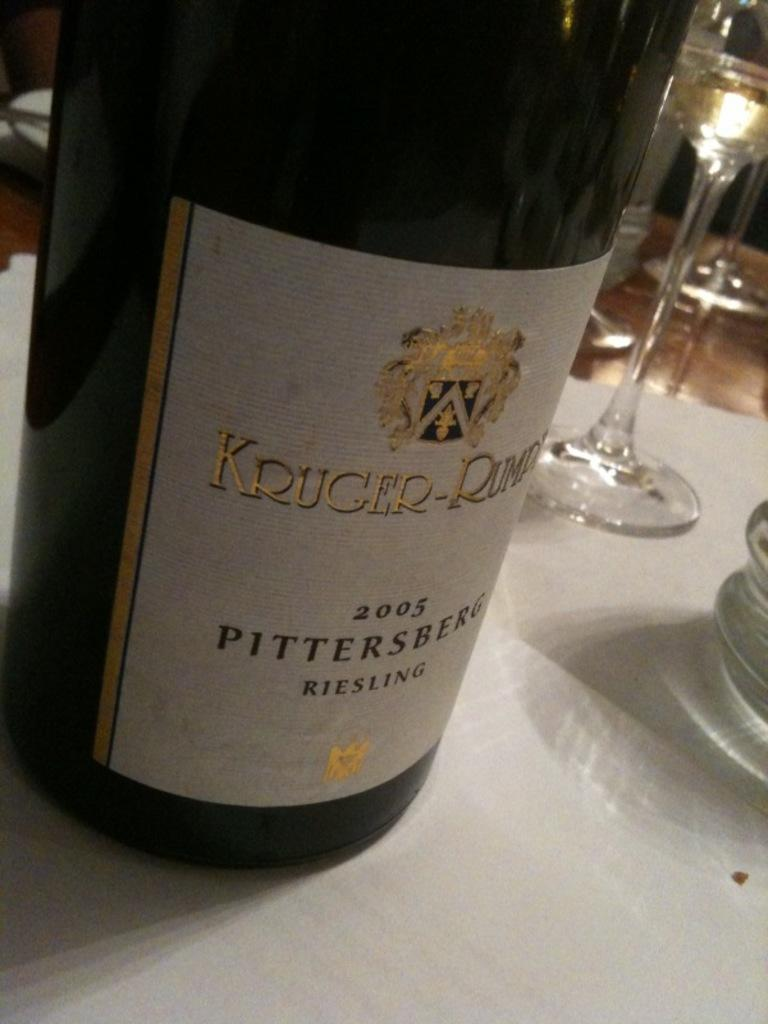What is present in the image that can hold liquids? There is a bottle and glasses in the image that can hold liquids. Where are the bottle and glasses located in the image? The bottle and glasses are on a platform in the image. How does the honey interact with the bottle and glasses in the image? There is no honey present in the image, so it cannot interact with the bottle and glasses. 